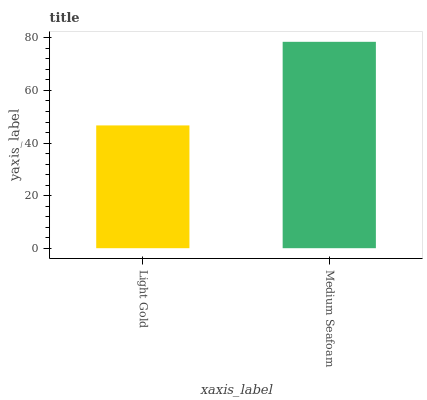Is Light Gold the minimum?
Answer yes or no. Yes. Is Medium Seafoam the maximum?
Answer yes or no. Yes. Is Medium Seafoam the minimum?
Answer yes or no. No. Is Medium Seafoam greater than Light Gold?
Answer yes or no. Yes. Is Light Gold less than Medium Seafoam?
Answer yes or no. Yes. Is Light Gold greater than Medium Seafoam?
Answer yes or no. No. Is Medium Seafoam less than Light Gold?
Answer yes or no. No. Is Medium Seafoam the high median?
Answer yes or no. Yes. Is Light Gold the low median?
Answer yes or no. Yes. Is Light Gold the high median?
Answer yes or no. No. Is Medium Seafoam the low median?
Answer yes or no. No. 